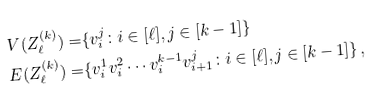Convert formula to latex. <formula><loc_0><loc_0><loc_500><loc_500>V ( Z _ { \ell } ^ { ( k ) } ) = & \{ v _ { i } ^ { j } \colon i \in [ \ell ] , j \in [ k - 1 ] \} \\ E ( Z _ { \ell } ^ { ( k ) } ) = & \{ v _ { i } ^ { 1 } v _ { i } ^ { 2 } \cdots v _ { i } ^ { k - 1 } v _ { i + 1 } ^ { j } \colon i \in [ \ell ] , j \in [ k - 1 ] \} \, ,</formula> 